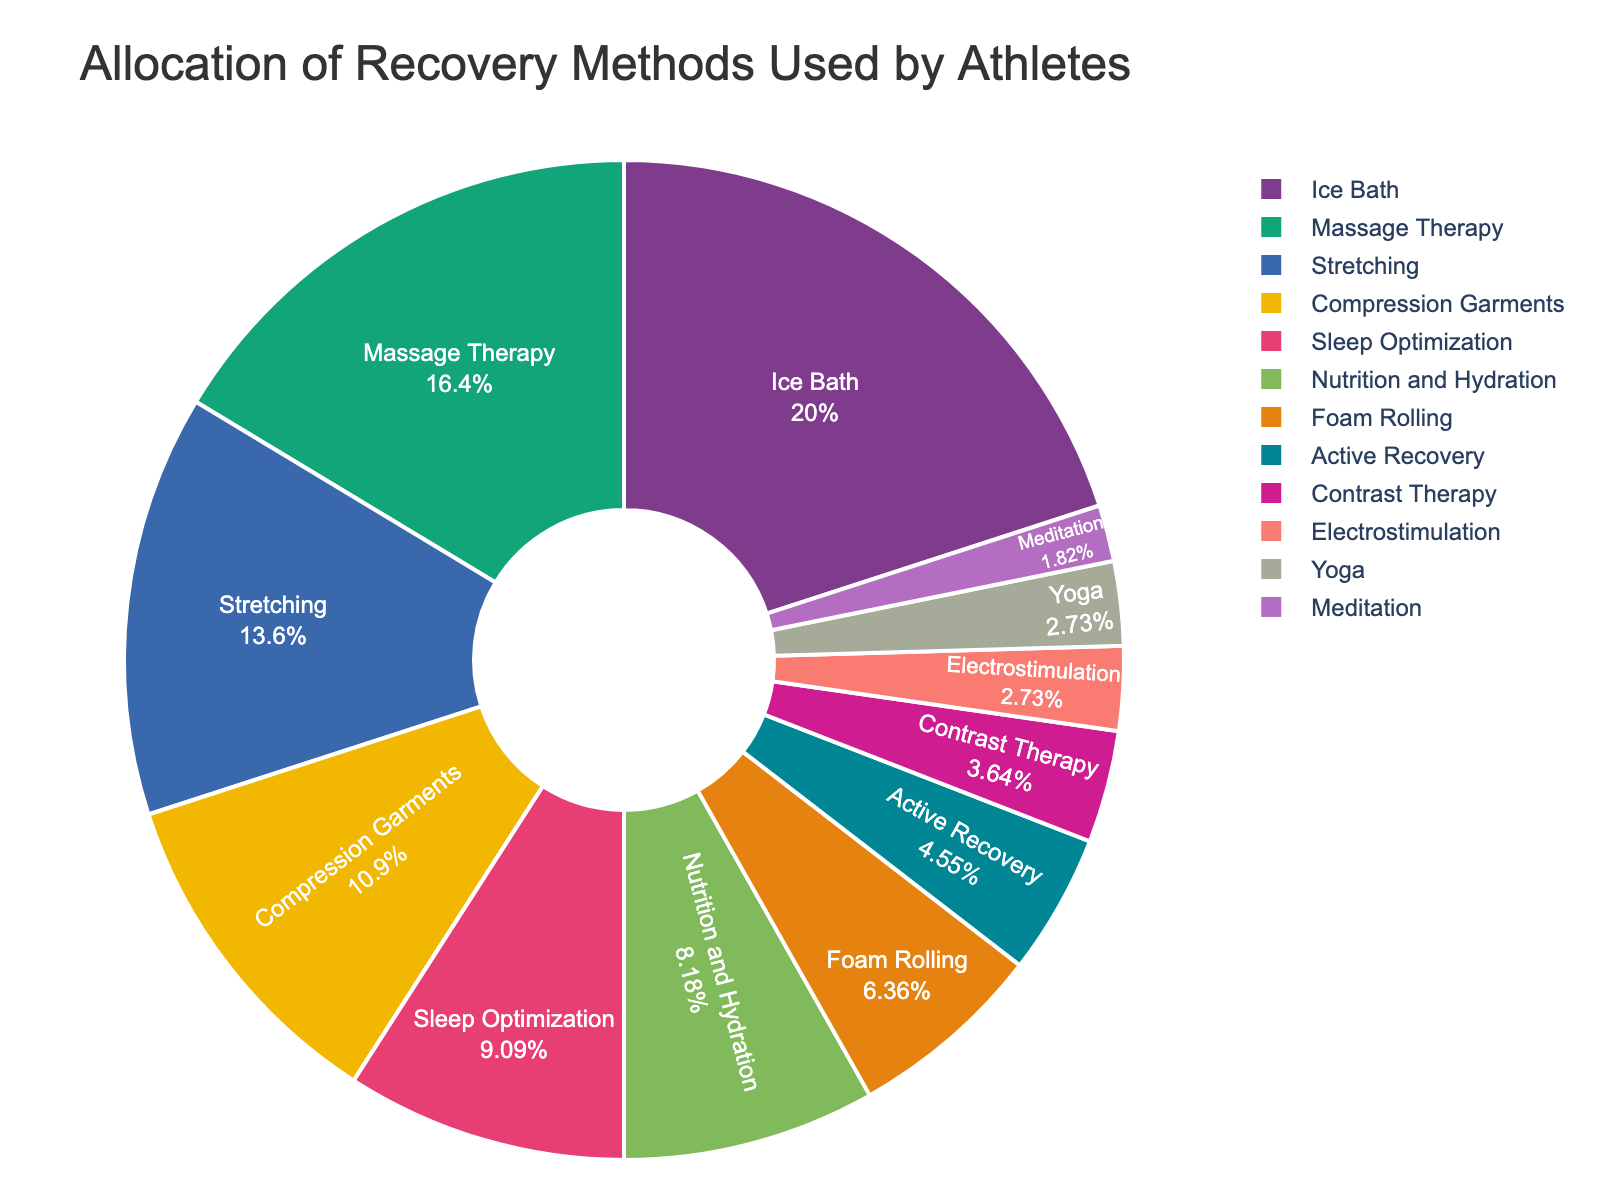Which recovery method is used the most by athletes? The recovery method with the highest percentage on the pie chart is the most used by athletes. In this pie chart, Ice Bath has the largest segment.
Answer: Ice Bath Which recovery method is least used by athletes? The recovery method with the smallest percentage on the pie chart is the least used by athletes. Meditation and Electrostimulation both have the smallest segments.
Answer: Meditation How many recovery methods have a usage percentage of less than 10%? By examining the pie chart, you can count the recovery methods with segments representing less than 10%. These methods are: Nutrition and Hydration (9%), Foam Rolling (7%), Active Recovery (5%), Contrast Therapy (4%), Electrostimulation (3%), Yoga (3%), and Meditation (2%).
Answer: 7 What is the combined percentage of Massage Therapy and Stretching? To find the combined percentage, add the percentages of Massage Therapy (18%) and Stretching (15%). 18% + 15% = 33%.
Answer: 33% Is Sleep Optimization used more or less than Compression Garments? By comparing the segments of Sleep Optimization (10%) and Compression Garments (12%), we see that Compression Garments have a larger segment.
Answer: Less Which recovery method has a percentage closest to 5%? The recovery method whose segment is closest to 5% in the pie chart is Active Recovery, which has exactly 5%.
Answer: Active Recovery Do Foam Rolling and Electrostimulation combined account for more than 10%? To determine if the combined percentages of Foam Rolling (7%) and Electrostimulation (3%) exceed 10%, add them together: 7% + 3% = 10%.
Answer: No Is the percentage of Yoga greater than or equal to the percentage of Meditation? By comparing the segments of Yoga (3%) and Meditation (2%) in the pie chart, Yoga has a greater percentage.
Answer: Greater Which segment is larger, Stretching or Sleep Optimization? Comparing the segments of Stretching (15%) and Sleep Optimization (10%) on the pie chart, Stretching has the larger segment.
Answer: Stretching What is the sum of the percentages for Ice Bath, Compression Garments, and Nutrition and Hydration? Add the percentages for Ice Bath (22%), Compression Garments (12%), and Nutrition and Hydration (9%). 22% + 12% + 9% = 43%.
Answer: 43% 